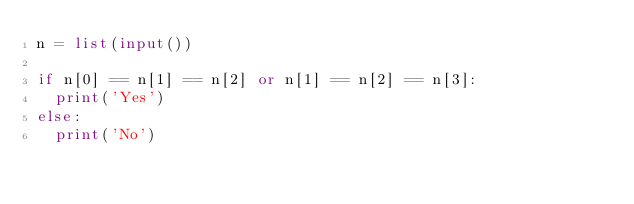<code> <loc_0><loc_0><loc_500><loc_500><_Python_>n = list(input())

if n[0] == n[1] == n[2] or n[1] == n[2] == n[3]:
  print('Yes')
else:
  print('No')</code> 